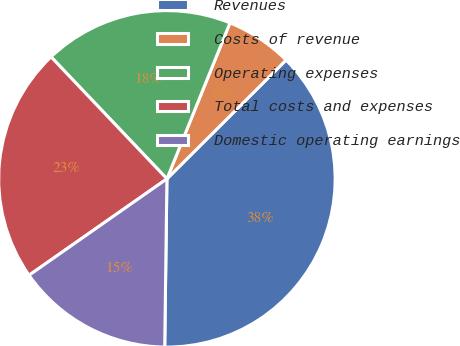Convert chart to OTSL. <chart><loc_0><loc_0><loc_500><loc_500><pie_chart><fcel>Revenues<fcel>Costs of revenue<fcel>Operating expenses<fcel>Total costs and expenses<fcel>Domestic operating earnings<nl><fcel>37.69%<fcel>6.41%<fcel>18.21%<fcel>22.62%<fcel>15.08%<nl></chart> 